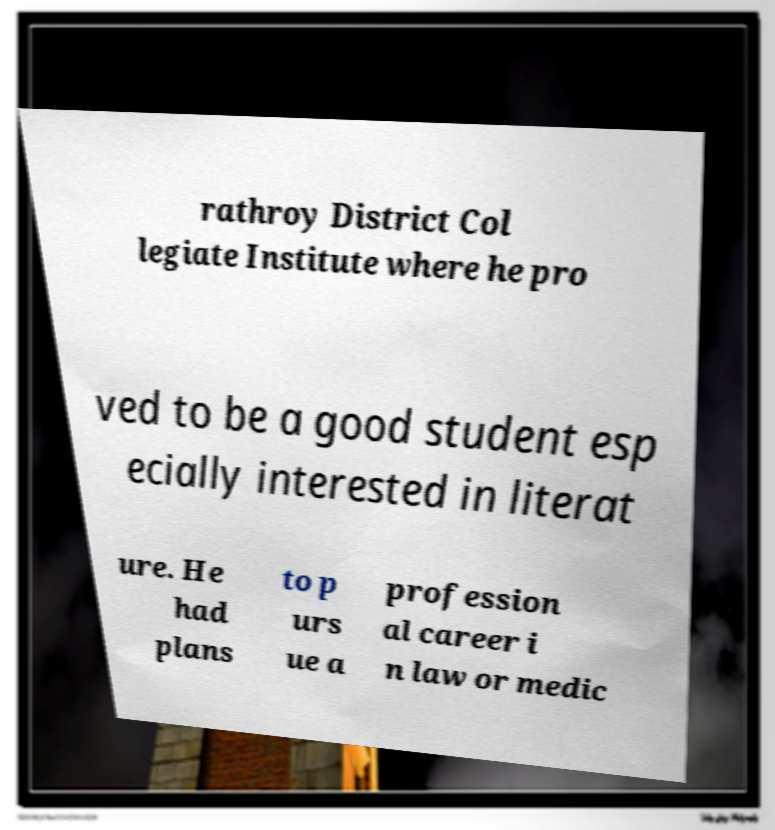Can you read and provide the text displayed in the image?This photo seems to have some interesting text. Can you extract and type it out for me? rathroy District Col legiate Institute where he pro ved to be a good student esp ecially interested in literat ure. He had plans to p urs ue a profession al career i n law or medic 